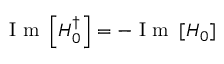<formula> <loc_0><loc_0><loc_500><loc_500>I m \left [ H _ { 0 } ^ { \dagger } \right ] = - I m \left [ H _ { 0 } \right ]</formula> 